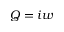<formula> <loc_0><loc_0><loc_500><loc_500>Q = i w</formula> 